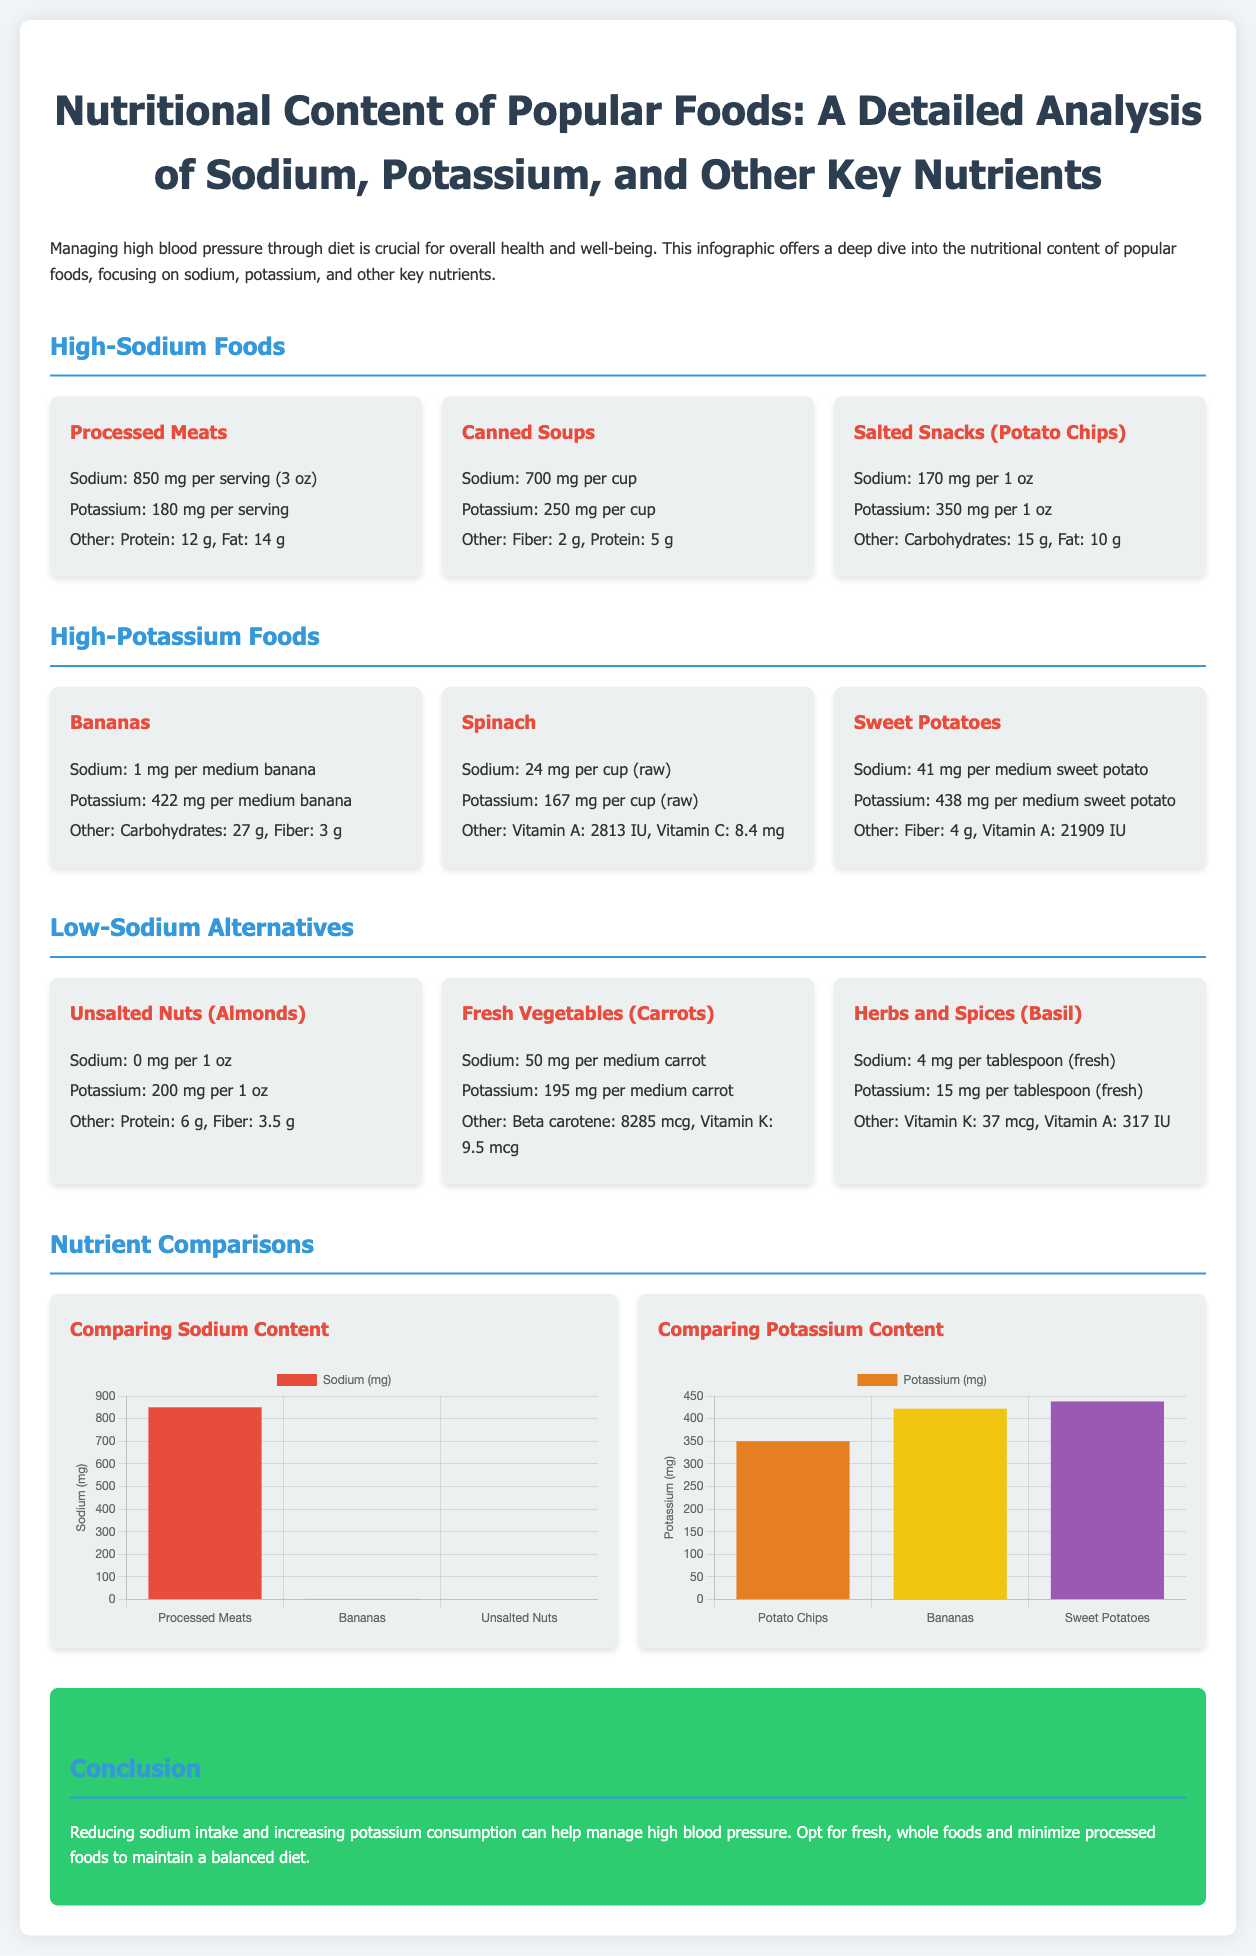What is the sodium content of processed meats? The sodium content of processed meats is specified in the document as 850 mg per serving (3 oz).
Answer: 850 mg What nutrient is found in the highest amount in bananas? The document highlights that bananas contain 422 mg of potassium per medium banana, which is their highest nutrient content listed.
Answer: Potassium Which food has the lowest sodium content? Based on the information presented about various foods, unsalted nuts (almonds) have the lowest sodium content at 0 mg per 1 oz.
Answer: 0 mg What is the potassium content of canned soups? The potassium content for canned soups is stated in the document as 250 mg per cup.
Answer: 250 mg Which food has more potassium, sweet potatoes or salted snacks (potato chips)? The document specifies that sweet potatoes contain 438 mg of potassium while potato chips have 350 mg, therefore sweet potatoes have more.
Answer: Sweet potatoes What is the primary dietary recommendation for managing high blood pressure? The conclusion section provides a key dietary recommendation for managing high blood pressure, which is to reduce sodium intake and increase potassium consumption.
Answer: Reduce sodium, increase potassium How many types of high-sodium foods are listed in the document? According to the sections outlined in the document, there are three types of high-sodium foods detailed.
Answer: Three types What is the calcium content in carrots? The document does not mention calcium content for carrots or any other foods listed.
Answer: Not mentioned What type of chart compares sodium content? The document employs a bar chart to visualize the sodium content in various foods among its sections.
Answer: Bar chart 